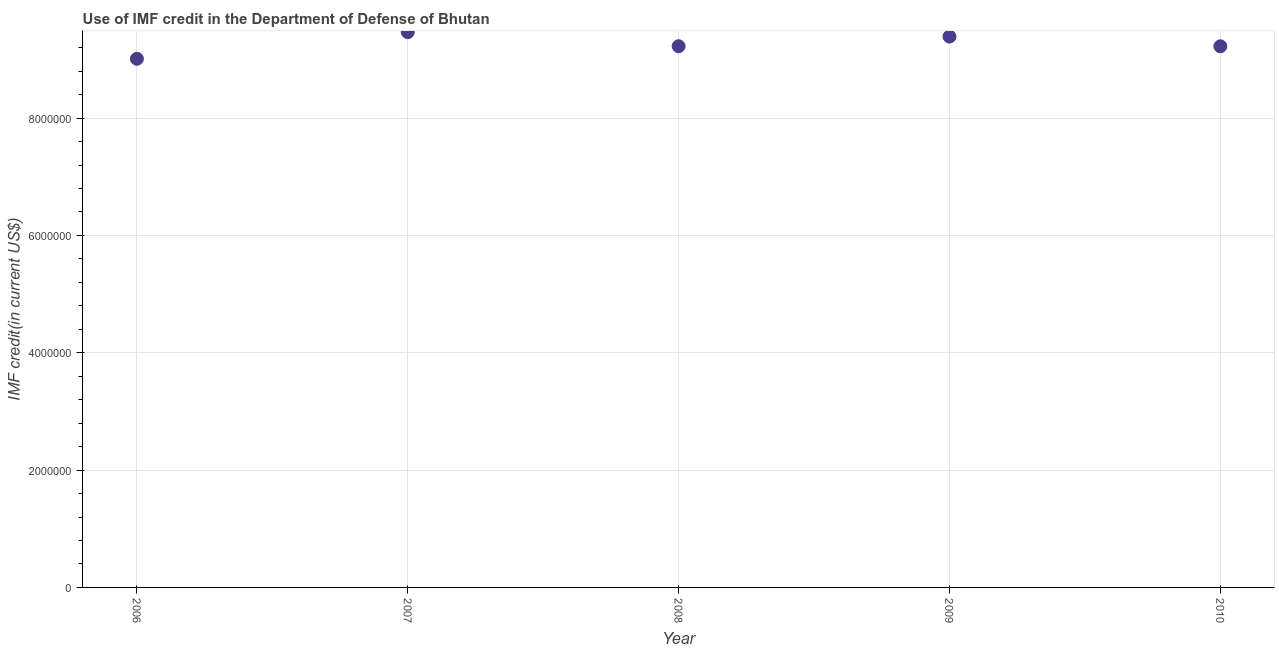What is the use of imf credit in dod in 2007?
Give a very brief answer. 9.46e+06. Across all years, what is the maximum use of imf credit in dod?
Keep it short and to the point. 9.46e+06. Across all years, what is the minimum use of imf credit in dod?
Make the answer very short. 9.01e+06. In which year was the use of imf credit in dod maximum?
Ensure brevity in your answer.  2007. In which year was the use of imf credit in dod minimum?
Your answer should be compact. 2006. What is the sum of the use of imf credit in dod?
Your answer should be very brief. 4.63e+07. What is the difference between the use of imf credit in dod in 2006 and 2008?
Provide a short and direct response. -2.14e+05. What is the average use of imf credit in dod per year?
Your response must be concise. 9.26e+06. What is the median use of imf credit in dod?
Your answer should be compact. 9.22e+06. What is the ratio of the use of imf credit in dod in 2007 to that in 2010?
Make the answer very short. 1.03. Is the use of imf credit in dod in 2008 less than that in 2009?
Make the answer very short. Yes. Is the difference between the use of imf credit in dod in 2008 and 2009 greater than the difference between any two years?
Make the answer very short. No. What is the difference between the highest and the second highest use of imf credit in dod?
Provide a succinct answer. 7.50e+04. What is the difference between the highest and the lowest use of imf credit in dod?
Provide a short and direct response. 4.54e+05. How many dotlines are there?
Your answer should be very brief. 1. How many years are there in the graph?
Your response must be concise. 5. What is the difference between two consecutive major ticks on the Y-axis?
Your answer should be compact. 2.00e+06. What is the title of the graph?
Offer a terse response. Use of IMF credit in the Department of Defense of Bhutan. What is the label or title of the Y-axis?
Ensure brevity in your answer.  IMF credit(in current US$). What is the IMF credit(in current US$) in 2006?
Your response must be concise. 9.01e+06. What is the IMF credit(in current US$) in 2007?
Keep it short and to the point. 9.46e+06. What is the IMF credit(in current US$) in 2008?
Your response must be concise. 9.22e+06. What is the IMF credit(in current US$) in 2009?
Your response must be concise. 9.39e+06. What is the IMF credit(in current US$) in 2010?
Provide a succinct answer. 9.22e+06. What is the difference between the IMF credit(in current US$) in 2006 and 2007?
Your answer should be very brief. -4.54e+05. What is the difference between the IMF credit(in current US$) in 2006 and 2008?
Provide a short and direct response. -2.14e+05. What is the difference between the IMF credit(in current US$) in 2006 and 2009?
Your answer should be very brief. -3.79e+05. What is the difference between the IMF credit(in current US$) in 2006 and 2010?
Give a very brief answer. -2.13e+05. What is the difference between the IMF credit(in current US$) in 2007 and 2009?
Your answer should be compact. 7.50e+04. What is the difference between the IMF credit(in current US$) in 2007 and 2010?
Provide a succinct answer. 2.41e+05. What is the difference between the IMF credit(in current US$) in 2008 and 2009?
Your answer should be compact. -1.65e+05. What is the difference between the IMF credit(in current US$) in 2009 and 2010?
Make the answer very short. 1.66e+05. What is the ratio of the IMF credit(in current US$) in 2006 to that in 2007?
Offer a very short reply. 0.95. What is the ratio of the IMF credit(in current US$) in 2006 to that in 2008?
Ensure brevity in your answer.  0.98. What is the ratio of the IMF credit(in current US$) in 2006 to that in 2010?
Provide a short and direct response. 0.98. What is the ratio of the IMF credit(in current US$) in 2007 to that in 2008?
Provide a short and direct response. 1.03. What is the ratio of the IMF credit(in current US$) in 2007 to that in 2010?
Provide a succinct answer. 1.03. What is the ratio of the IMF credit(in current US$) in 2008 to that in 2009?
Keep it short and to the point. 0.98. What is the ratio of the IMF credit(in current US$) in 2008 to that in 2010?
Make the answer very short. 1. What is the ratio of the IMF credit(in current US$) in 2009 to that in 2010?
Your response must be concise. 1.02. 